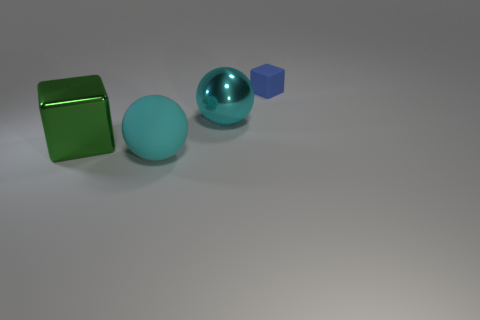Add 1 cyan things. How many objects exist? 5 Add 3 blue blocks. How many blue blocks are left? 4 Add 3 tiny red metallic cylinders. How many tiny red metallic cylinders exist? 3 Subtract 0 yellow cylinders. How many objects are left? 4 Subtract all tiny things. Subtract all big metallic balls. How many objects are left? 2 